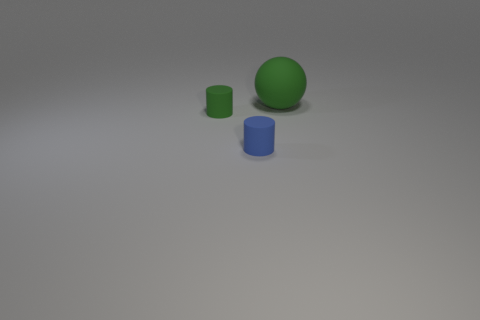Is there anything else that is the same size as the sphere?
Your response must be concise. No. What is the green object in front of the rubber ball made of?
Your answer should be very brief. Rubber. What material is the green thing that is the same shape as the small blue rubber object?
Your answer should be very brief. Rubber. There is a green thing left of the large green thing; is there a green object that is right of it?
Provide a succinct answer. Yes. Is the tiny green thing the same shape as the big green matte thing?
Your response must be concise. No. What shape is the tiny object that is the same material as the blue cylinder?
Your answer should be very brief. Cylinder. There is a green matte thing to the left of the sphere; does it have the same size as the green rubber thing to the right of the blue object?
Ensure brevity in your answer.  No. Are there more tiny matte cylinders right of the small blue cylinder than small blue things left of the sphere?
Ensure brevity in your answer.  No. What number of other objects are the same color as the large thing?
Your response must be concise. 1. Is the color of the big ball the same as the tiny thing behind the blue cylinder?
Ensure brevity in your answer.  Yes. 